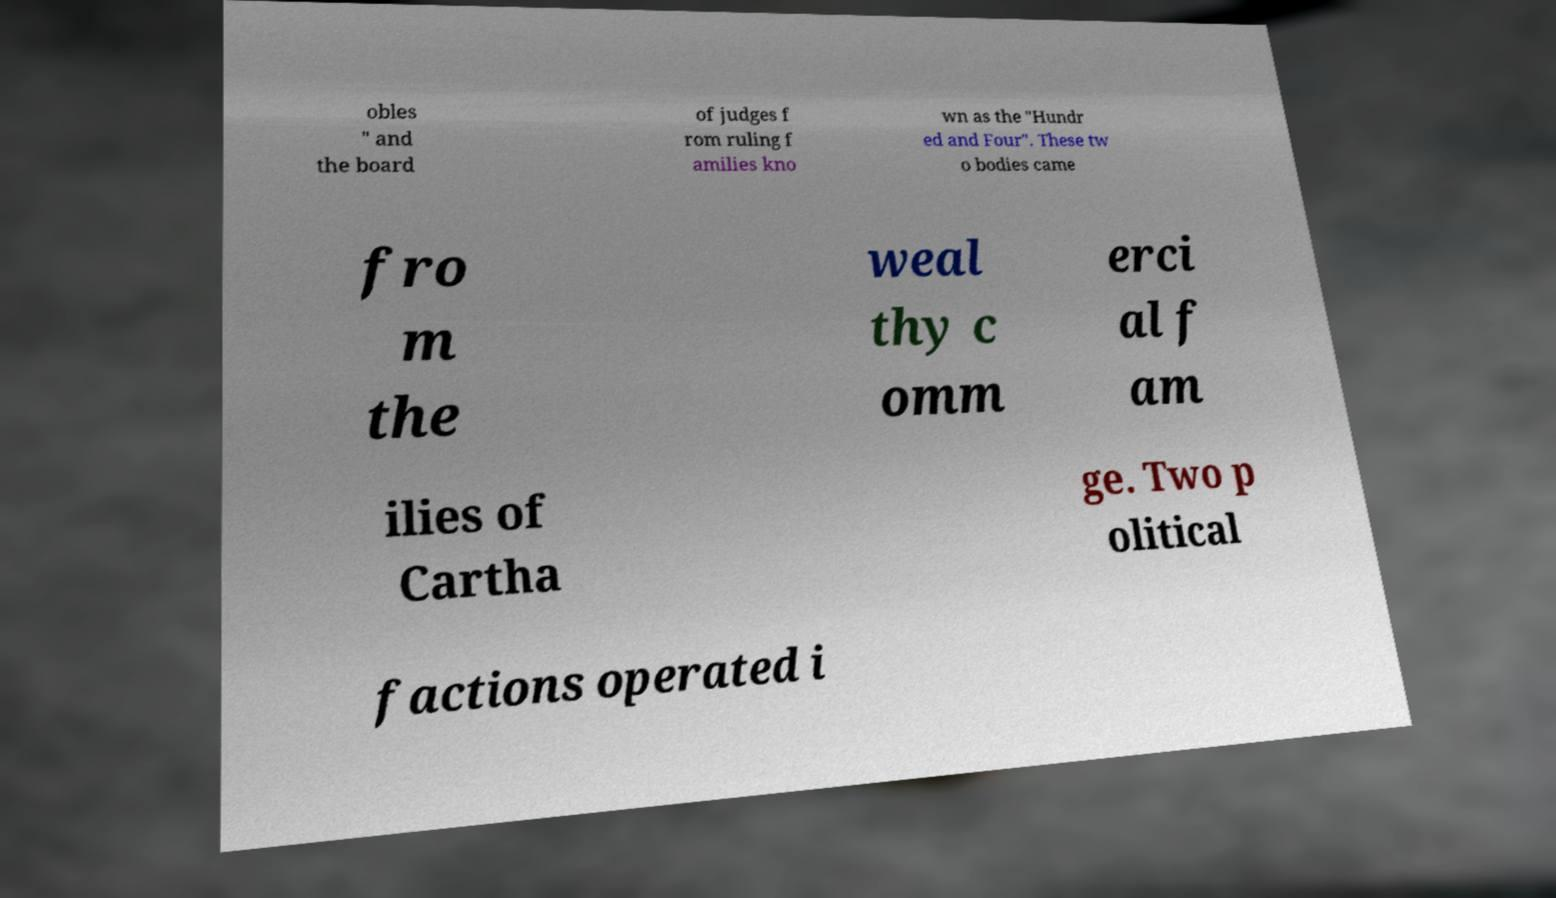There's text embedded in this image that I need extracted. Can you transcribe it verbatim? obles " and the board of judges f rom ruling f amilies kno wn as the "Hundr ed and Four". These tw o bodies came fro m the weal thy c omm erci al f am ilies of Cartha ge. Two p olitical factions operated i 